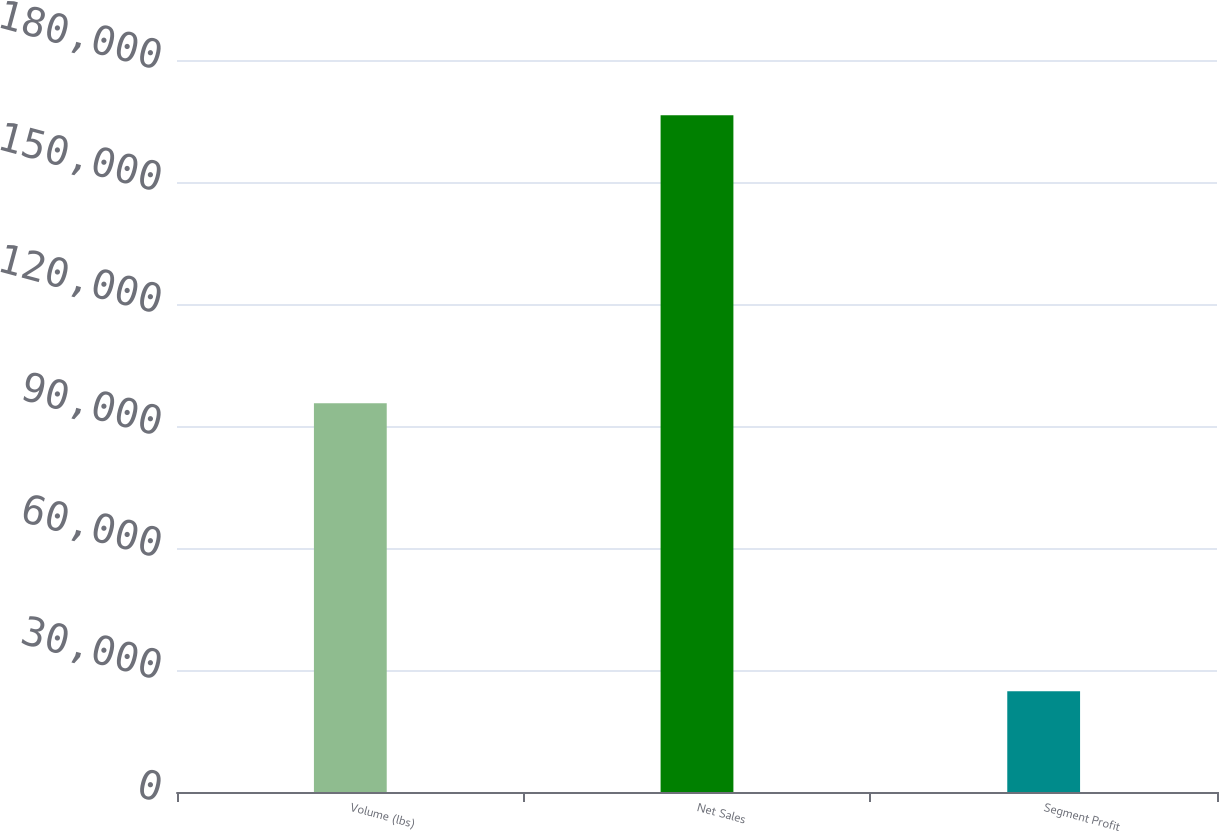Convert chart to OTSL. <chart><loc_0><loc_0><loc_500><loc_500><bar_chart><fcel>Volume (lbs)<fcel>Net Sales<fcel>Segment Profit<nl><fcel>95600<fcel>166391<fcel>24802<nl></chart> 